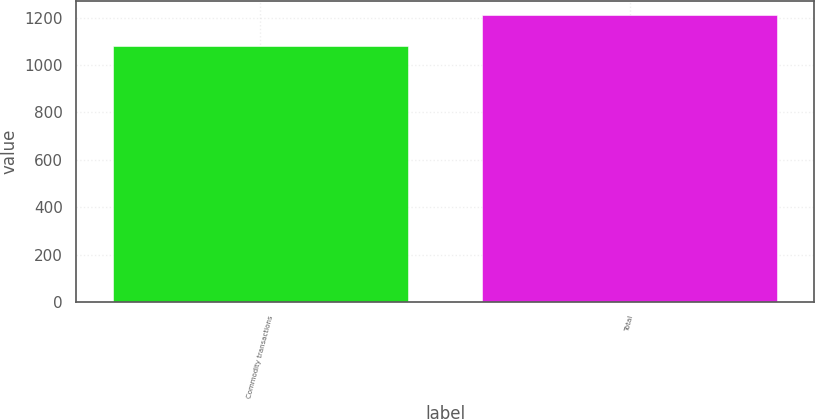<chart> <loc_0><loc_0><loc_500><loc_500><bar_chart><fcel>Commodity transactions<fcel>Total<nl><fcel>1080<fcel>1210<nl></chart> 